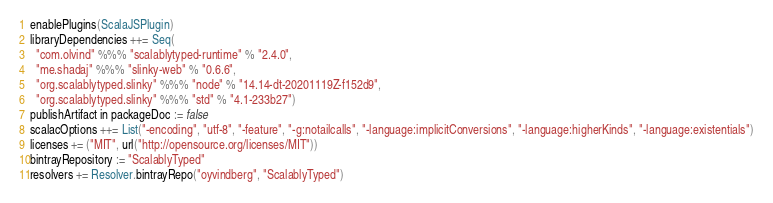Convert code to text. <code><loc_0><loc_0><loc_500><loc_500><_Scala_>enablePlugins(ScalaJSPlugin)
libraryDependencies ++= Seq(
  "com.olvind" %%% "scalablytyped-runtime" % "2.4.0",
  "me.shadaj" %%% "slinky-web" % "0.6.6",
  "org.scalablytyped.slinky" %%% "node" % "14.14-dt-20201119Z-f152d9",
  "org.scalablytyped.slinky" %%% "std" % "4.1-233b27")
publishArtifact in packageDoc := false
scalacOptions ++= List("-encoding", "utf-8", "-feature", "-g:notailcalls", "-language:implicitConversions", "-language:higherKinds", "-language:existentials")
licenses += ("MIT", url("http://opensource.org/licenses/MIT"))
bintrayRepository := "ScalablyTyped"
resolvers += Resolver.bintrayRepo("oyvindberg", "ScalablyTyped")
</code> 